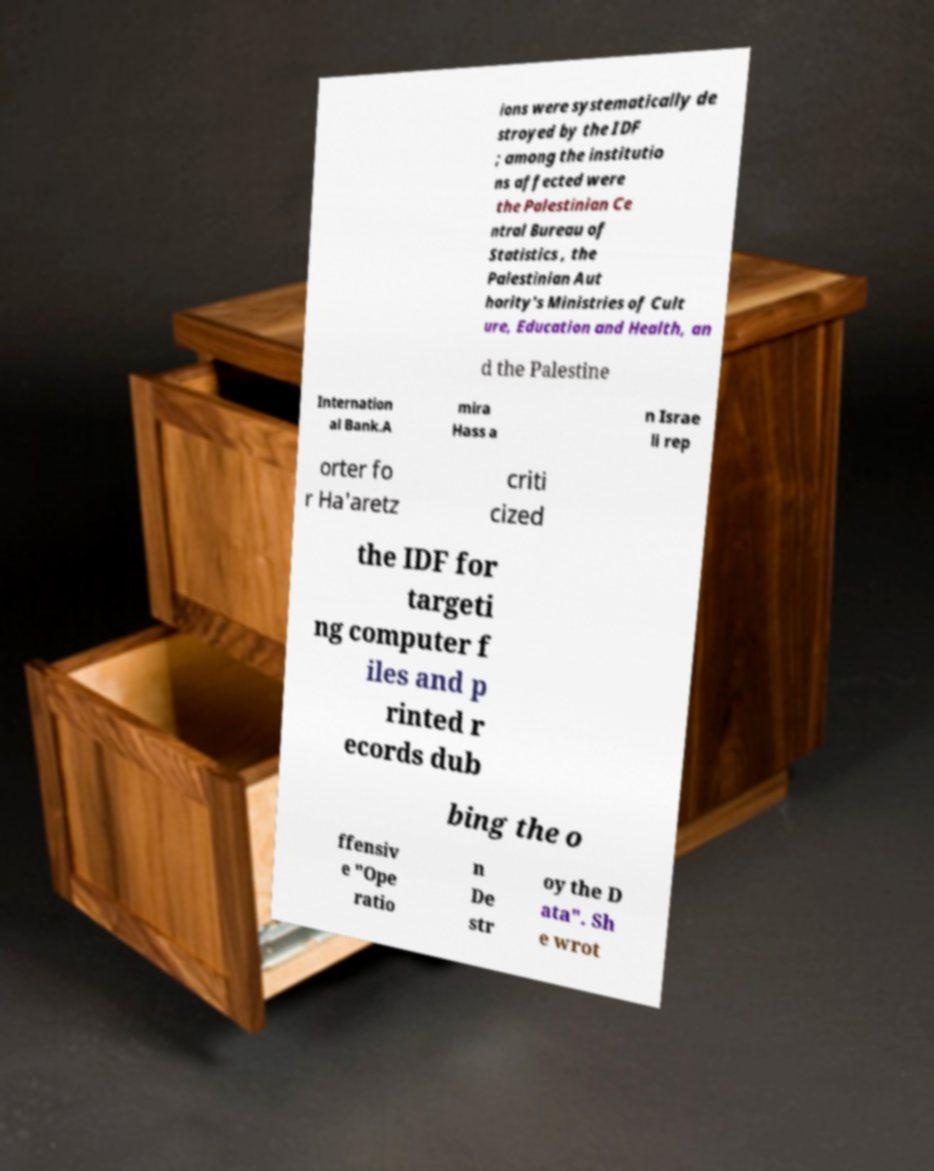I need the written content from this picture converted into text. Can you do that? ions were systematically de stroyed by the IDF ; among the institutio ns affected were the Palestinian Ce ntral Bureau of Statistics , the Palestinian Aut hority's Ministries of Cult ure, Education and Health, an d the Palestine Internation al Bank.A mira Hass a n Israe li rep orter fo r Ha'aretz criti cized the IDF for targeti ng computer f iles and p rinted r ecords dub bing the o ffensiv e "Ope ratio n De str oy the D ata". Sh e wrot 